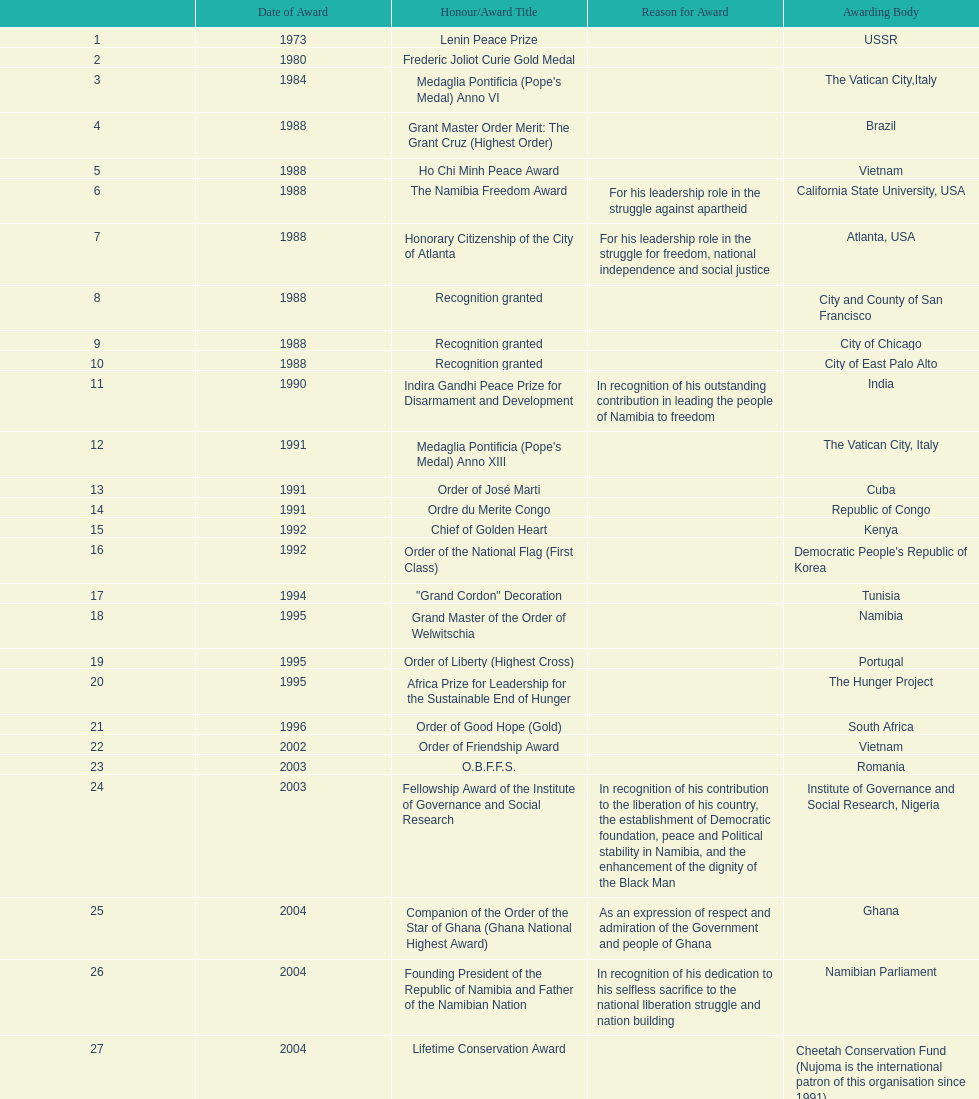Based on this chart, what is the total count of honors/award titles listed? 29. 